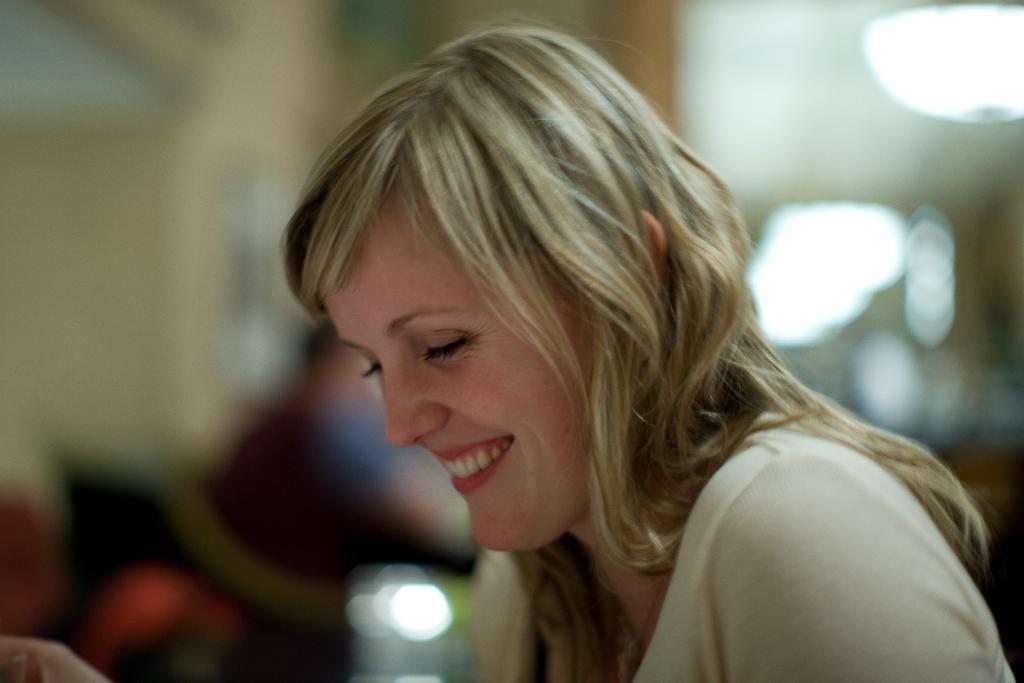Describe this image in one or two sentences. In this picture, we can see a lady, and we can see the background is blurred. 